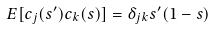Convert formula to latex. <formula><loc_0><loc_0><loc_500><loc_500>E [ c _ { j } ( s ^ { \prime } ) c _ { k } ( s ) ] = \delta _ { j k } s ^ { \prime } ( 1 - s )</formula> 